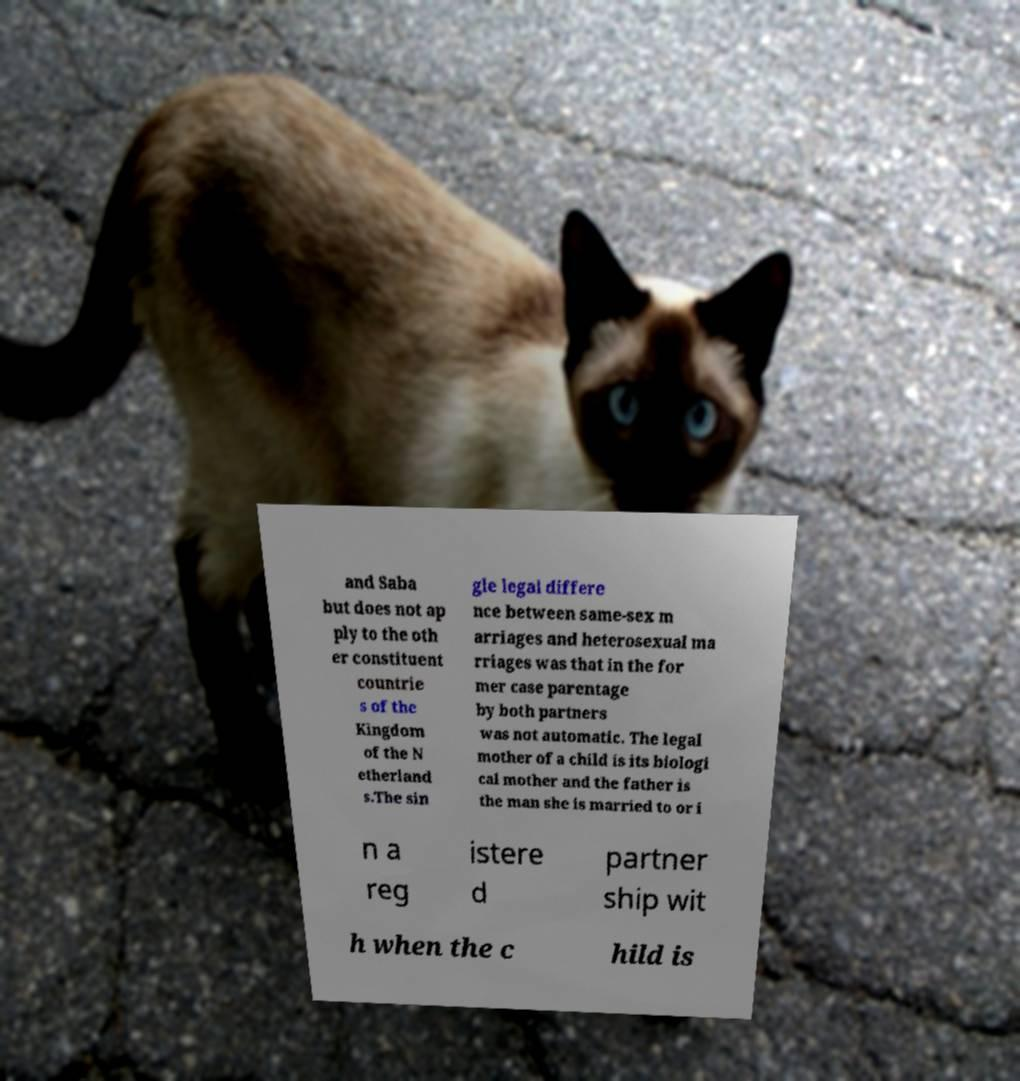There's text embedded in this image that I need extracted. Can you transcribe it verbatim? and Saba but does not ap ply to the oth er constituent countrie s of the Kingdom of the N etherland s.The sin gle legal differe nce between same-sex m arriages and heterosexual ma rriages was that in the for mer case parentage by both partners was not automatic. The legal mother of a child is its biologi cal mother and the father is the man she is married to or i n a reg istere d partner ship wit h when the c hild is 